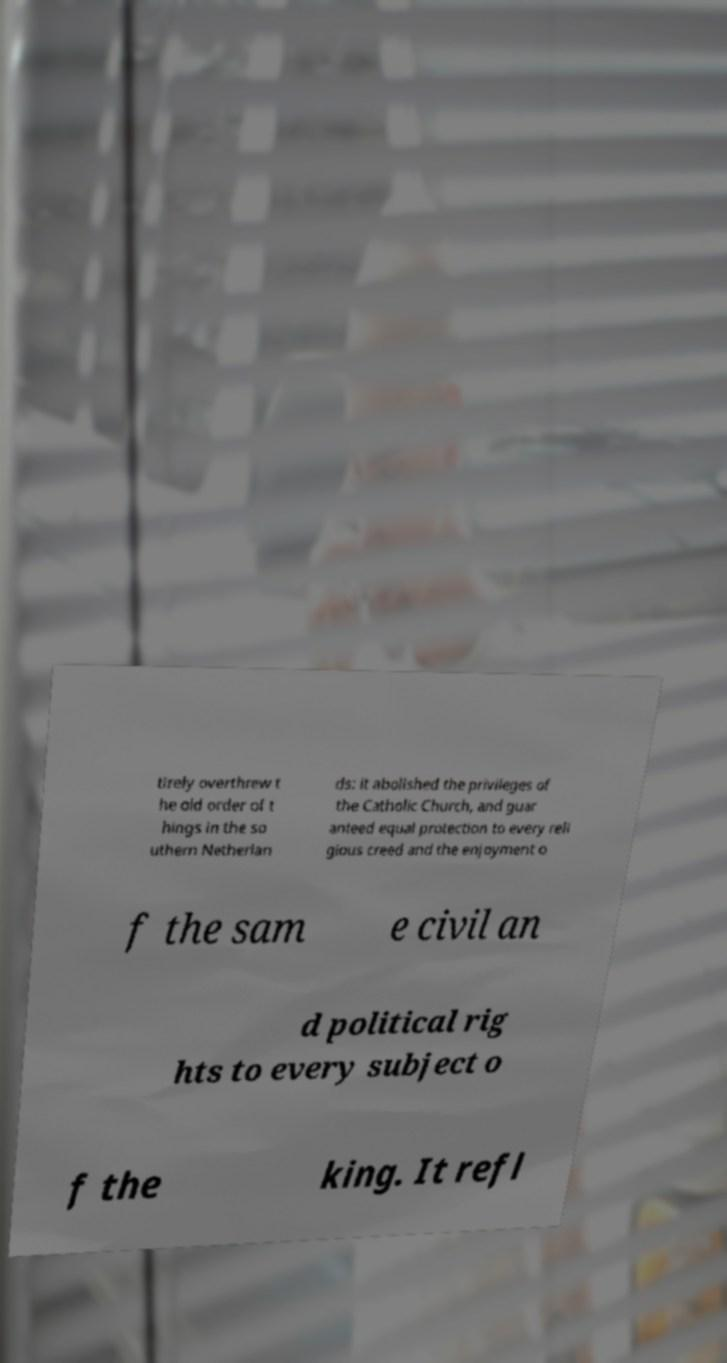I need the written content from this picture converted into text. Can you do that? tirely overthrew t he old order of t hings in the so uthern Netherlan ds: it abolished the privileges of the Catholic Church, and guar anteed equal protection to every reli gious creed and the enjoyment o f the sam e civil an d political rig hts to every subject o f the king. It refl 